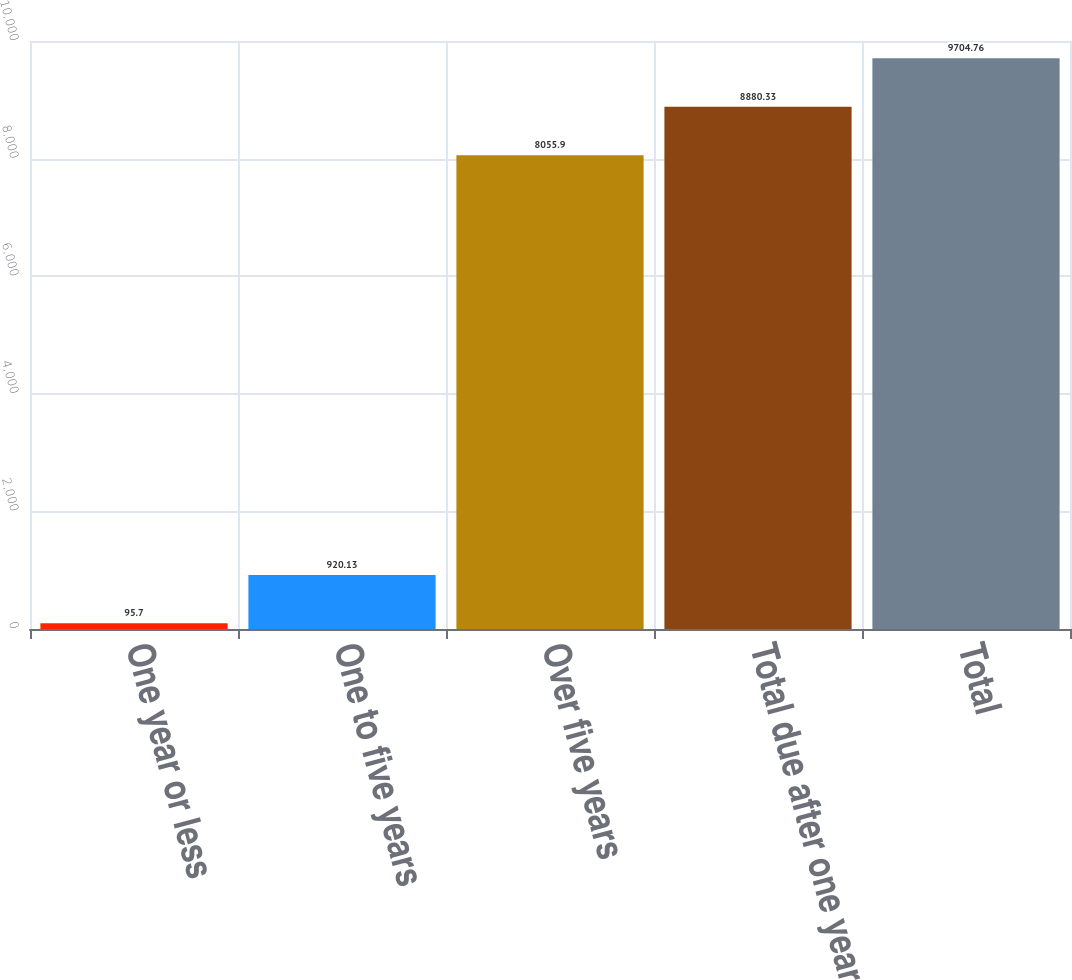<chart> <loc_0><loc_0><loc_500><loc_500><bar_chart><fcel>One year or less<fcel>One to five years<fcel>Over five years<fcel>Total due after one year<fcel>Total<nl><fcel>95.7<fcel>920.13<fcel>8055.9<fcel>8880.33<fcel>9704.76<nl></chart> 